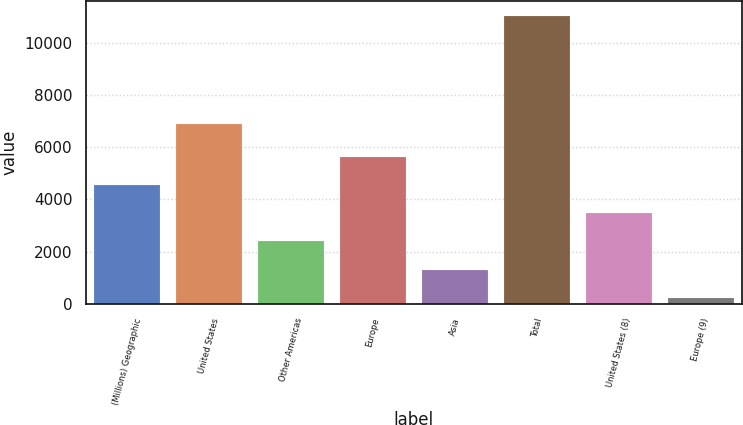<chart> <loc_0><loc_0><loc_500><loc_500><bar_chart><fcel>(Millions) Geographic<fcel>United States<fcel>Other Americas<fcel>Europe<fcel>Asia<fcel>Total<fcel>United States (8)<fcel>Europe (9)<nl><fcel>4549.8<fcel>6878<fcel>2387.4<fcel>5631<fcel>1306.2<fcel>11037<fcel>3468.6<fcel>225<nl></chart> 